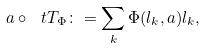<formula> <loc_0><loc_0><loc_500><loc_500>a \circ \ t T _ { \Phi } \colon = \sum _ { k } \Phi ( l _ { k } , a ) l _ { k } ,</formula> 